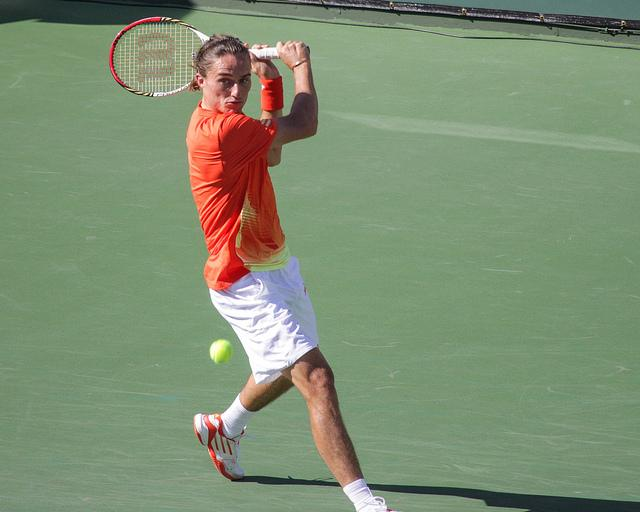Why is the man holding the racket back? Please explain your reasoning. to swing. He is preparing to perform a back swing. 